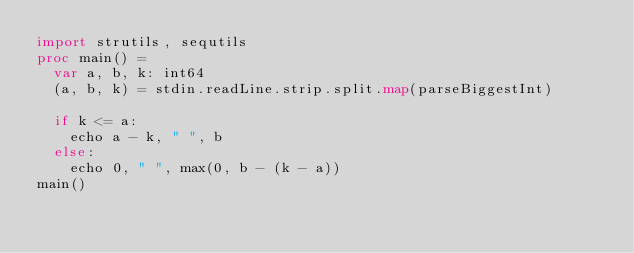<code> <loc_0><loc_0><loc_500><loc_500><_Nim_>import strutils, sequtils
proc main() =
  var a, b, k: int64
  (a, b, k) = stdin.readLine.strip.split.map(parseBiggestInt)

  if k <= a:
    echo a - k, " ", b
  else:
    echo 0, " ", max(0, b - (k - a))
main()
</code> 